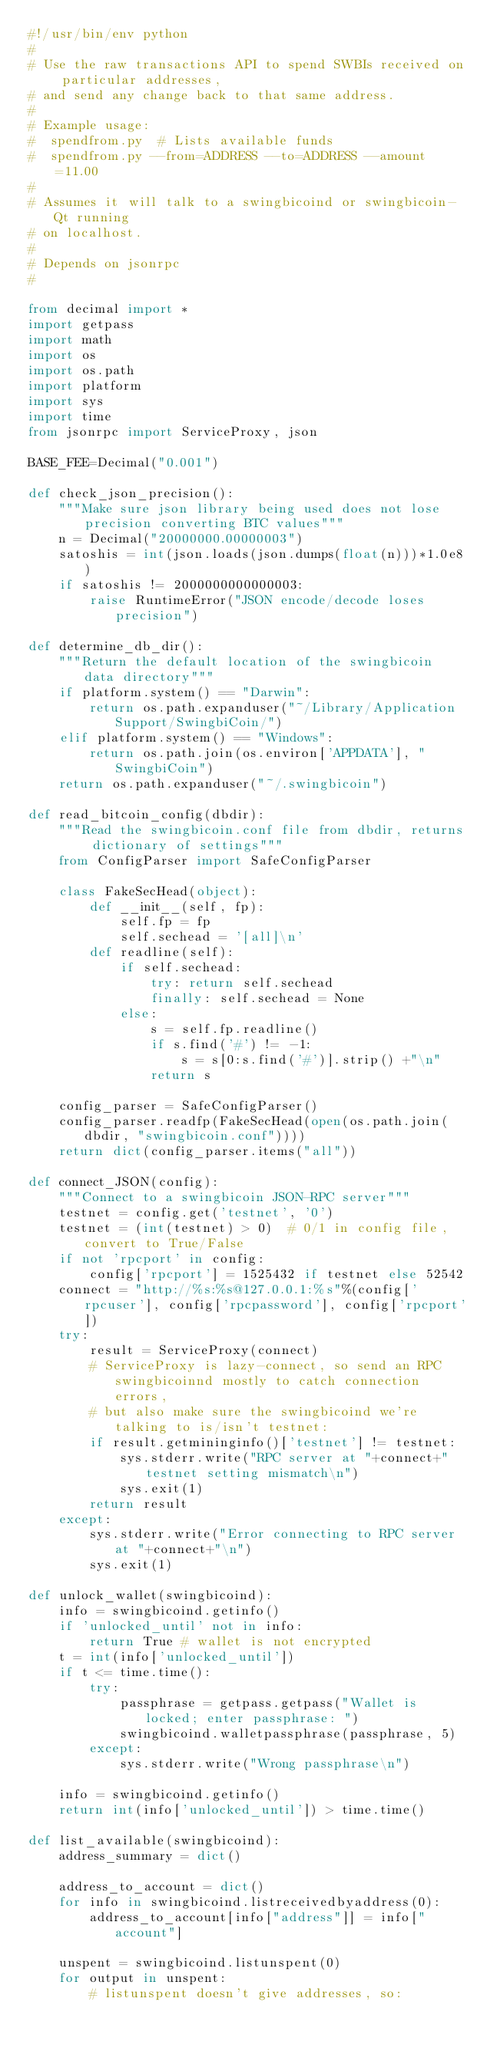Convert code to text. <code><loc_0><loc_0><loc_500><loc_500><_Python_>#!/usr/bin/env python
#
# Use the raw transactions API to spend SWBIs received on particular addresses,
# and send any change back to that same address.
#
# Example usage:
#  spendfrom.py  # Lists available funds
#  spendfrom.py --from=ADDRESS --to=ADDRESS --amount=11.00
#
# Assumes it will talk to a swingbicoind or swingbicoin-Qt running
# on localhost.
#
# Depends on jsonrpc
#

from decimal import *
import getpass
import math
import os
import os.path
import platform
import sys
import time
from jsonrpc import ServiceProxy, json

BASE_FEE=Decimal("0.001")

def check_json_precision():
    """Make sure json library being used does not lose precision converting BTC values"""
    n = Decimal("20000000.00000003")
    satoshis = int(json.loads(json.dumps(float(n)))*1.0e8)
    if satoshis != 2000000000000003:
        raise RuntimeError("JSON encode/decode loses precision")

def determine_db_dir():
    """Return the default location of the swingbicoin data directory"""
    if platform.system() == "Darwin":
        return os.path.expanduser("~/Library/Application Support/SwingbiCoin/")
    elif platform.system() == "Windows":
        return os.path.join(os.environ['APPDATA'], "SwingbiCoin")
    return os.path.expanduser("~/.swingbicoin")

def read_bitcoin_config(dbdir):
    """Read the swingbicoin.conf file from dbdir, returns dictionary of settings"""
    from ConfigParser import SafeConfigParser

    class FakeSecHead(object):
        def __init__(self, fp):
            self.fp = fp
            self.sechead = '[all]\n'
        def readline(self):
            if self.sechead:
                try: return self.sechead
                finally: self.sechead = None
            else:
                s = self.fp.readline()
                if s.find('#') != -1:
                    s = s[0:s.find('#')].strip() +"\n"
                return s

    config_parser = SafeConfigParser()
    config_parser.readfp(FakeSecHead(open(os.path.join(dbdir, "swingbicoin.conf"))))
    return dict(config_parser.items("all"))

def connect_JSON(config):
    """Connect to a swingbicoin JSON-RPC server"""
    testnet = config.get('testnet', '0')
    testnet = (int(testnet) > 0)  # 0/1 in config file, convert to True/False
    if not 'rpcport' in config:
        config['rpcport'] = 1525432 if testnet else 52542
    connect = "http://%s:%s@127.0.0.1:%s"%(config['rpcuser'], config['rpcpassword'], config['rpcport'])
    try:
        result = ServiceProxy(connect)
        # ServiceProxy is lazy-connect, so send an RPC swingbicoinnd mostly to catch connection errors,
        # but also make sure the swingbicoind we're talking to is/isn't testnet:
        if result.getmininginfo()['testnet'] != testnet:
            sys.stderr.write("RPC server at "+connect+" testnet setting mismatch\n")
            sys.exit(1)
        return result
    except:
        sys.stderr.write("Error connecting to RPC server at "+connect+"\n")
        sys.exit(1)

def unlock_wallet(swingbicoind):
    info = swingbicoind.getinfo()
    if 'unlocked_until' not in info:
        return True # wallet is not encrypted
    t = int(info['unlocked_until'])
    if t <= time.time():
        try:
            passphrase = getpass.getpass("Wallet is locked; enter passphrase: ")
            swingbicoind.walletpassphrase(passphrase, 5)
        except:
            sys.stderr.write("Wrong passphrase\n")

    info = swingbicoind.getinfo()
    return int(info['unlocked_until']) > time.time()

def list_available(swingbicoind):
    address_summary = dict()

    address_to_account = dict()
    for info in swingbicoind.listreceivedbyaddress(0):
        address_to_account[info["address"]] = info["account"]

    unspent = swingbicoind.listunspent(0)
    for output in unspent:
        # listunspent doesn't give addresses, so:</code> 